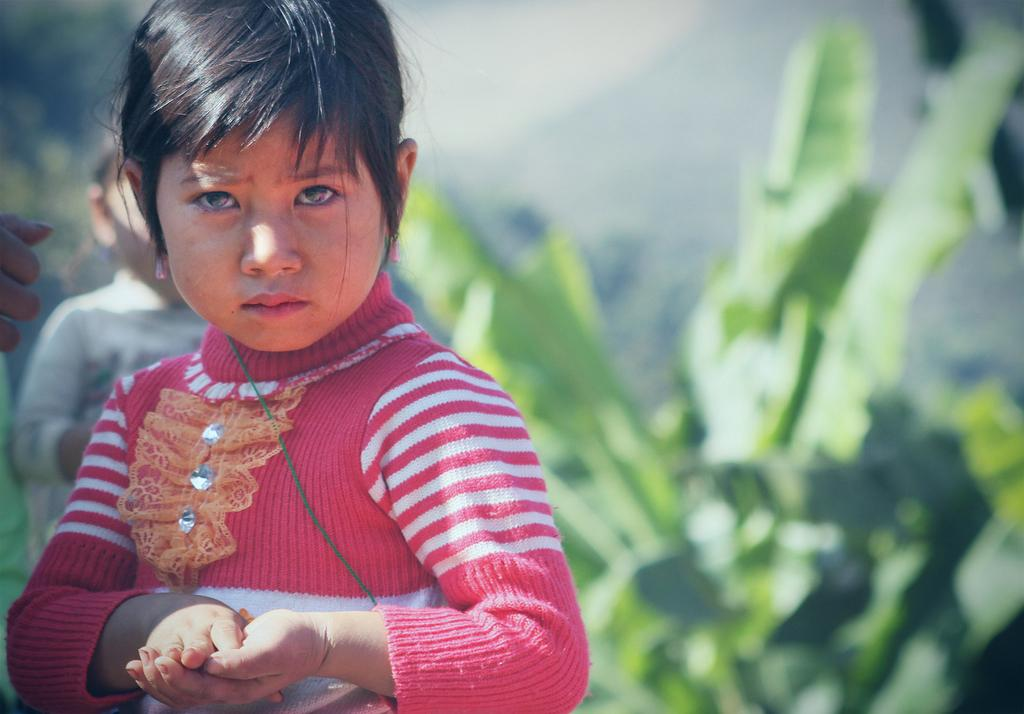How many people are in the image? There are a few people in the image. What else can be seen in the image besides the people? There are plants in the image. Can you describe the background of the image? The background of the image is blurred. Is there a cemetery visible in the image? There is no mention of a cemetery in the provided facts, and therefore it cannot be determined if one is present in the image. 